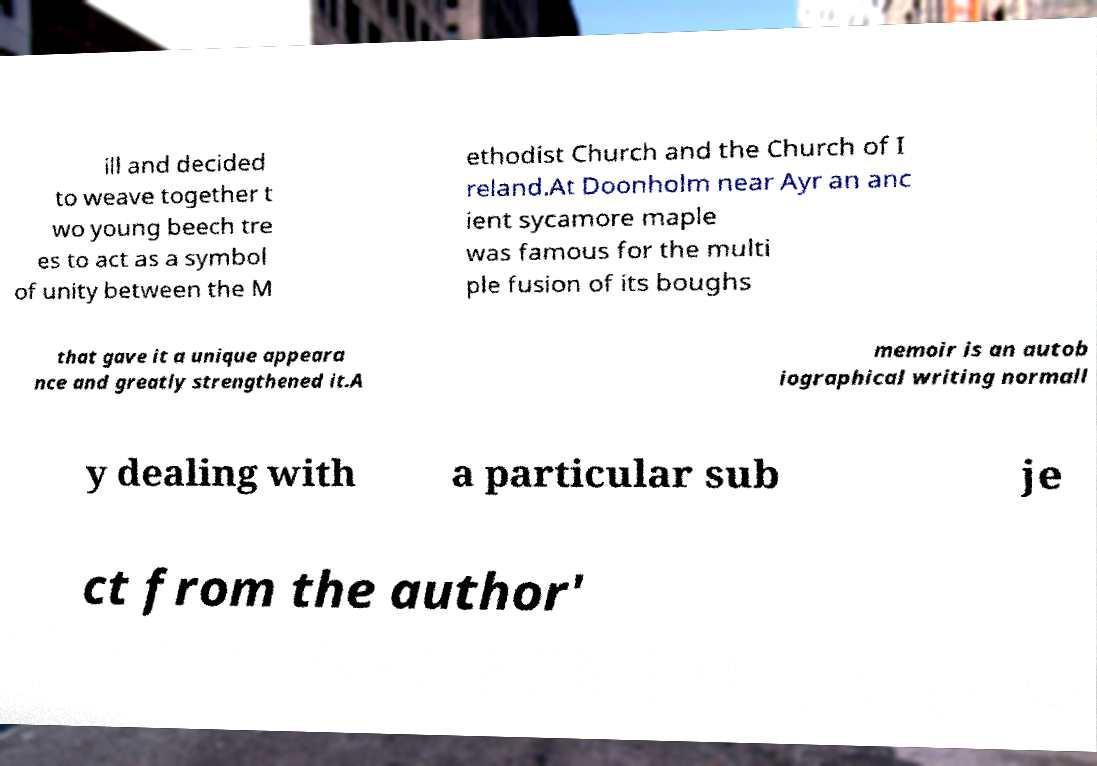Please read and relay the text visible in this image. What does it say? ill and decided to weave together t wo young beech tre es to act as a symbol of unity between the M ethodist Church and the Church of I reland.At Doonholm near Ayr an anc ient sycamore maple was famous for the multi ple fusion of its boughs that gave it a unique appeara nce and greatly strengthened it.A memoir is an autob iographical writing normall y dealing with a particular sub je ct from the author' 